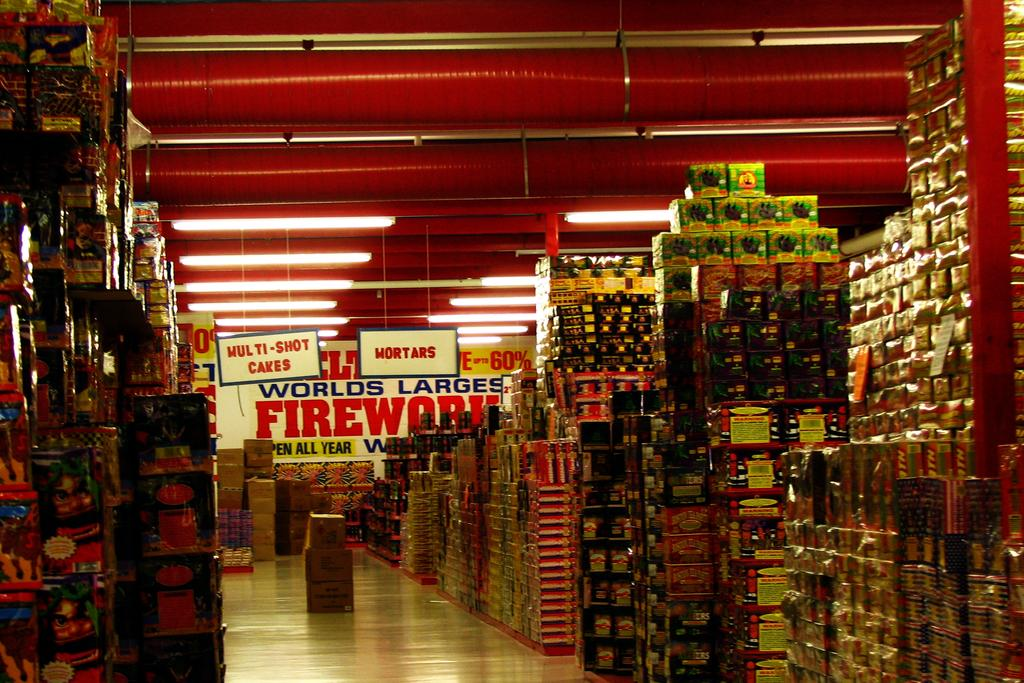<image>
Present a compact description of the photo's key features. Inside this store is the world's largest fireworks selection for sale. 